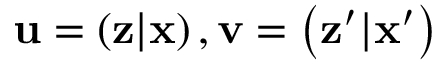<formula> <loc_0><loc_0><loc_500><loc_500>u = \left ( z | x \right ) , v = \left ( z ^ { \prime } | x ^ { \prime } \right )</formula> 